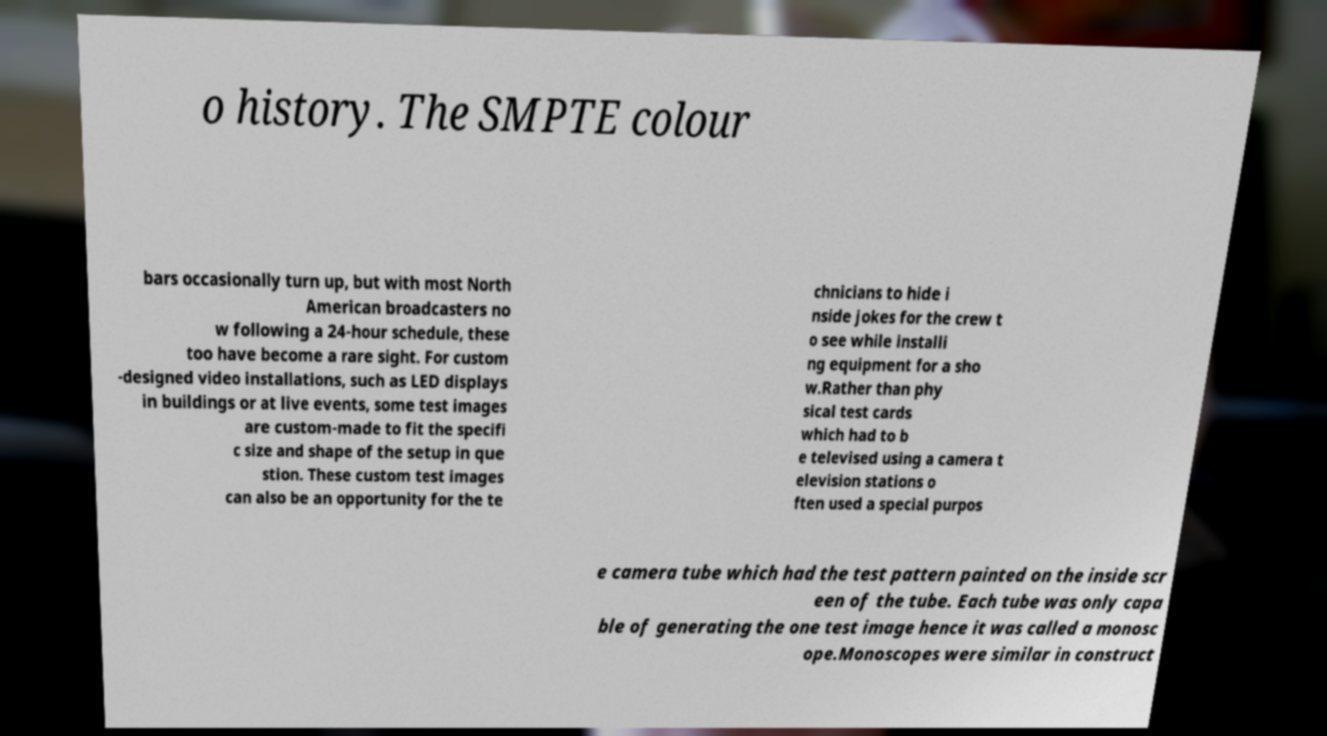I need the written content from this picture converted into text. Can you do that? o history. The SMPTE colour bars occasionally turn up, but with most North American broadcasters no w following a 24-hour schedule, these too have become a rare sight. For custom -designed video installations, such as LED displays in buildings or at live events, some test images are custom-made to fit the specifi c size and shape of the setup in que stion. These custom test images can also be an opportunity for the te chnicians to hide i nside jokes for the crew t o see while installi ng equipment for a sho w.Rather than phy sical test cards which had to b e televised using a camera t elevision stations o ften used a special purpos e camera tube which had the test pattern painted on the inside scr een of the tube. Each tube was only capa ble of generating the one test image hence it was called a monosc ope.Monoscopes were similar in construct 